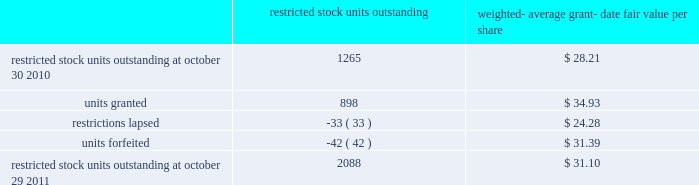The total intrinsic value of options exercised ( i.e .
The difference between the market price at exercise and the price paid by the employee to exercise the options ) during fiscal 2011 , 2010 and 2009 was $ 96.5 million , $ 29.6 million and $ 4.7 million , respectively .
The total amount of proceeds received by the company from exercise of these options during fiscal 2011 , 2010 and 2009 was $ 217.4 million , $ 240.4 million and $ 15.1 million , respectively .
Proceeds from stock option exercises pursuant to employee stock plans in the company 2019s statement of cash flows of $ 217.2 million , $ 216.1 million and $ 12.4 million for fiscal 2011 , 2010 and 2009 , respectively , are net of the value of shares surrendered by employees in certain limited circumstances to satisfy the exercise price of options , and to satisfy employee tax obligations upon vesting of restricted stock or restricted stock units and in connection with the exercise of stock options granted to the company 2019s employees under the company 2019s equity compensation plans .
The withholding amount is based on the company 2019s minimum statutory withholding requirement .
A summary of the company 2019s restricted stock unit award activity as of october 29 , 2011 and changes during the year then ended is presented below : restricted outstanding weighted- average grant- date fair value per share .
As of october 29 , 2011 , there was $ 88.6 million of total unrecognized compensation cost related to unvested share-based awards comprised of stock options and restricted stock units .
That cost is expected to be recognized over a weighted-average period of 1.3 years .
The total grant-date fair value of shares that vested during fiscal 2011 , 2010 and 2009 was approximately $ 49.6 million , $ 67.7 million and $ 74.4 million , respectively .
Common stock repurchase program the company 2019s common stock repurchase program has been in place since august 2004 .
In the aggregate , the board of directors has authorized the company to repurchase $ 5 billion of the company 2019s common stock under the program .
Under the program , the company may repurchase outstanding shares of its common stock from time to time in the open market and through privately negotiated transactions .
Unless terminated earlier by resolution of the company 2019s board of directors , the repurchase program will expire when the company has repurchased all shares authorized under the program .
As of october 29 , 2011 , the company had repurchased a total of approximately 125.0 million shares of its common stock for approximately $ 4278.5 million under this program .
An additional $ 721.5 million remains available for repurchase of shares under the current authorized program .
The repurchased shares are held as authorized but unissued shares of common stock .
Any future common stock repurchases will be dependent upon several factors , including the amount of cash available to the company in the united states and the company 2019s financial performance , outlook and liquidity .
The company also from time to time repurchases shares in settlement of employee tax withholding obligations due upon the vesting of restricted stock units , or in certain limited circumstances to satisfy the exercise price of options granted to the company 2019s employees under the company 2019s equity compensation plans .
Analog devices , inc .
Notes to consolidated financial statements 2014 ( continued ) .
What was the average share price that the shares were repurchased in 2011? 
Rationale: to find the average price that the company repurchase it shares at one must divide the amount paid by the number of shares bought .
Computations: (4278.5 / 125.0)
Answer: 34.228. 